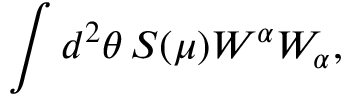<formula> <loc_0><loc_0><loc_500><loc_500>\int d ^ { 2 } \theta \, S ( \mu ) W ^ { \alpha } W _ { \alpha } ,</formula> 